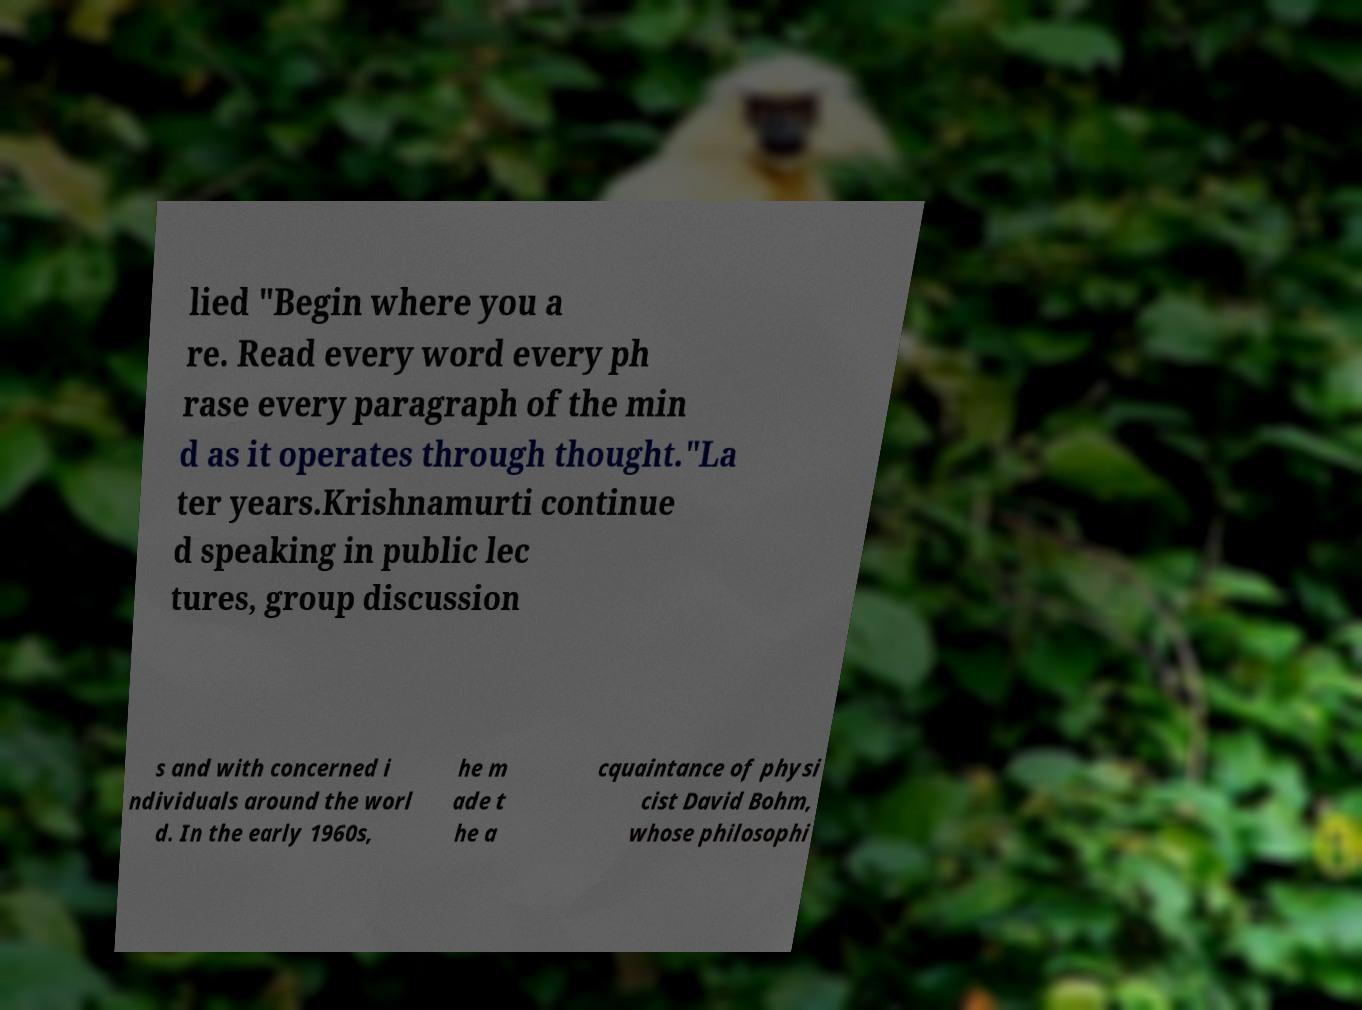What messages or text are displayed in this image? I need them in a readable, typed format. lied "Begin where you a re. Read every word every ph rase every paragraph of the min d as it operates through thought."La ter years.Krishnamurti continue d speaking in public lec tures, group discussion s and with concerned i ndividuals around the worl d. In the early 1960s, he m ade t he a cquaintance of physi cist David Bohm, whose philosophi 